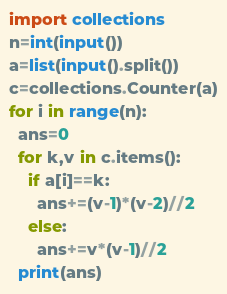<code> <loc_0><loc_0><loc_500><loc_500><_Python_>import collections
n=int(input())
a=list(input().split())
c=collections.Counter(a)
for i in range(n):
  ans=0
  for k,v in c.items():
    if a[i]==k:
      ans+=(v-1)*(v-2)//2
    else:
      ans+=v*(v-1)//2
  print(ans)

</code> 